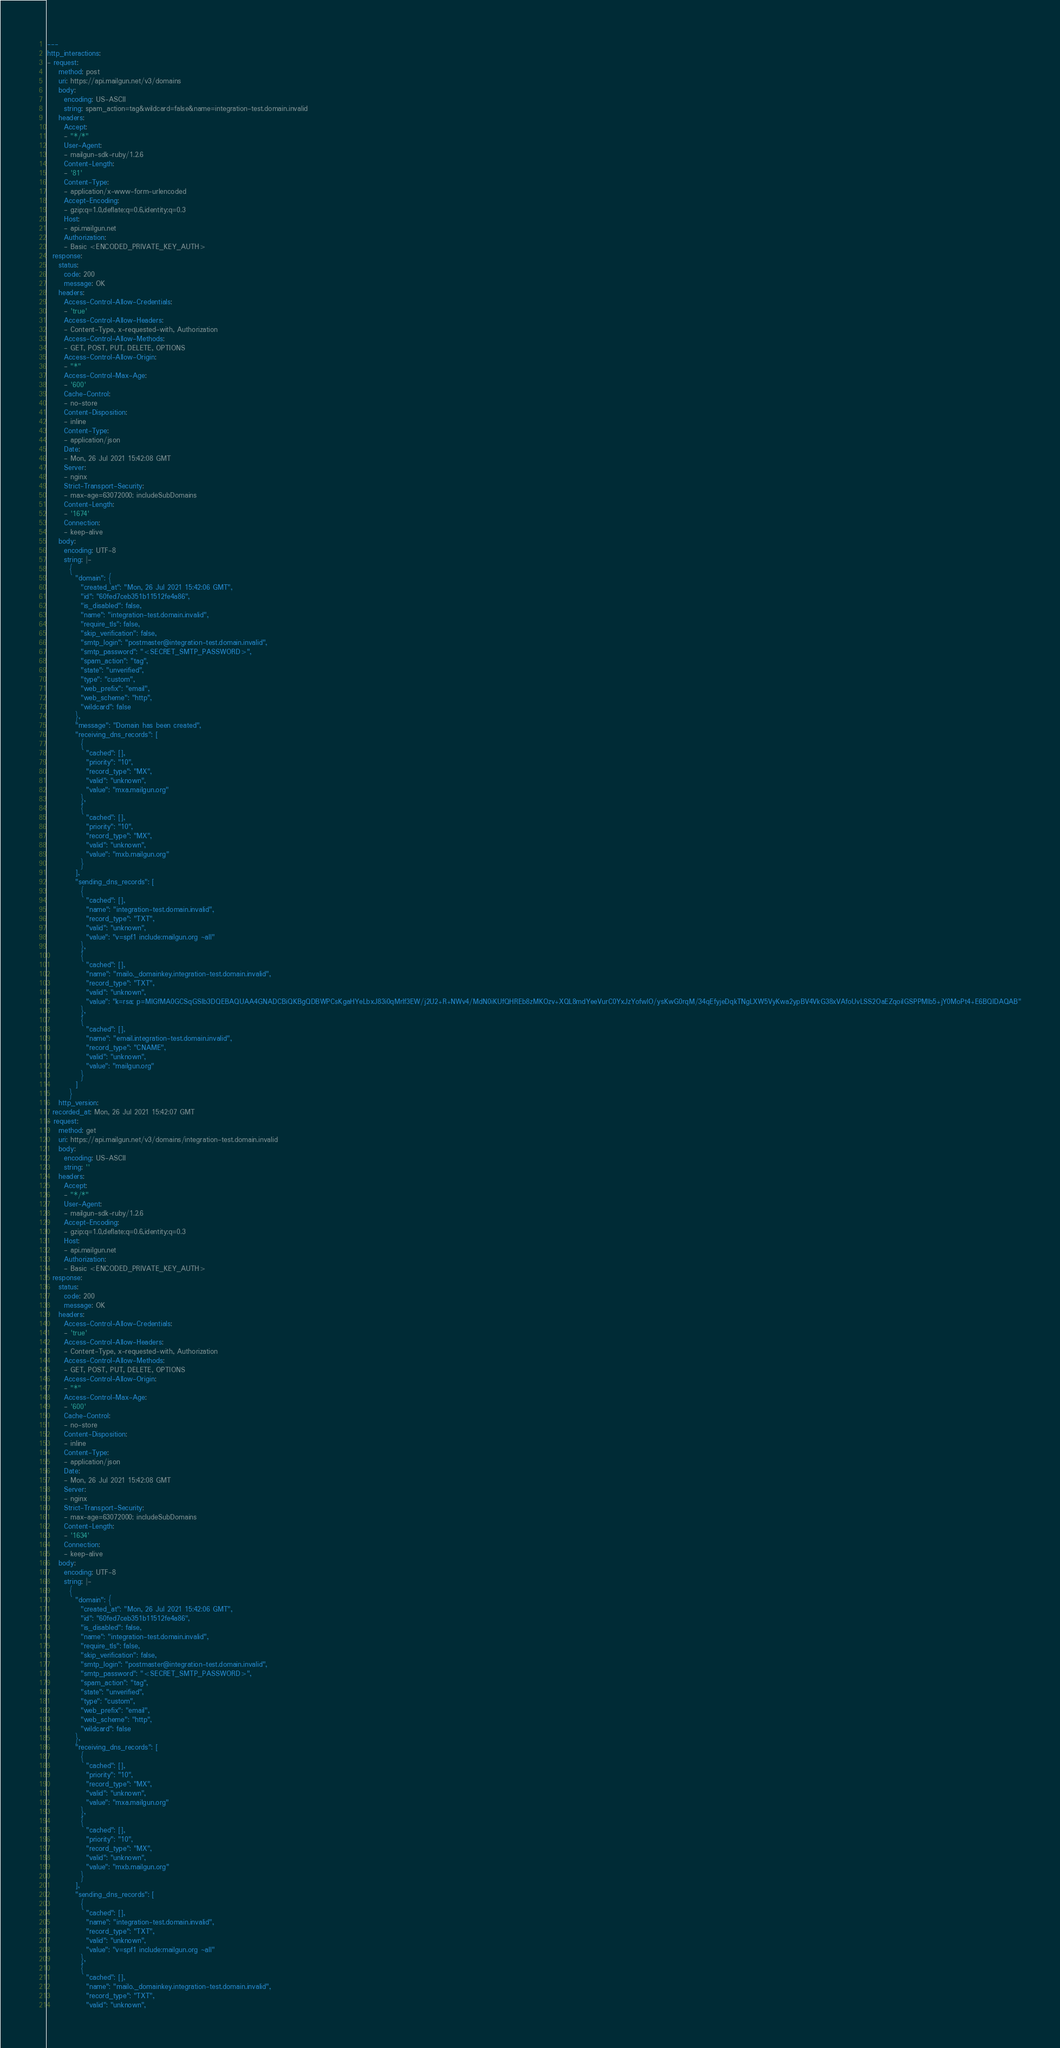Convert code to text. <code><loc_0><loc_0><loc_500><loc_500><_YAML_>---
http_interactions:
- request:
    method: post
    uri: https://api.mailgun.net/v3/domains
    body:
      encoding: US-ASCII
      string: spam_action=tag&wildcard=false&name=integration-test.domain.invalid
    headers:
      Accept:
      - "*/*"
      User-Agent:
      - mailgun-sdk-ruby/1.2.6
      Content-Length:
      - '81'
      Content-Type:
      - application/x-www-form-urlencoded
      Accept-Encoding:
      - gzip;q=1.0,deflate;q=0.6,identity;q=0.3
      Host:
      - api.mailgun.net
      Authorization:
      - Basic <ENCODED_PRIVATE_KEY_AUTH>
  response:
    status:
      code: 200
      message: OK
    headers:
      Access-Control-Allow-Credentials:
      - 'true'
      Access-Control-Allow-Headers:
      - Content-Type, x-requested-with, Authorization
      Access-Control-Allow-Methods:
      - GET, POST, PUT, DELETE, OPTIONS
      Access-Control-Allow-Origin:
      - "*"
      Access-Control-Max-Age:
      - '600'
      Cache-Control:
      - no-store
      Content-Disposition:
      - inline
      Content-Type:
      - application/json
      Date:
      - Mon, 26 Jul 2021 15:42:08 GMT
      Server:
      - nginx
      Strict-Transport-Security:
      - max-age=63072000; includeSubDomains
      Content-Length:
      - '1674'
      Connection:
      - keep-alive
    body:
      encoding: UTF-8
      string: |-
        {
          "domain": {
            "created_at": "Mon, 26 Jul 2021 15:42:06 GMT",
            "id": "60fed7ceb351b11512fe4a86",
            "is_disabled": false,
            "name": "integration-test.domain.invalid",
            "require_tls": false,
            "skip_verification": false,
            "smtp_login": "postmaster@integration-test.domain.invalid",
            "smtp_password": "<SECRET_SMTP_PASSWORD>",
            "spam_action": "tag",
            "state": "unverified",
            "type": "custom",
            "web_prefix": "email",
            "web_scheme": "http",
            "wildcard": false
          },
          "message": "Domain has been created",
          "receiving_dns_records": [
            {
              "cached": [],
              "priority": "10",
              "record_type": "MX",
              "valid": "unknown",
              "value": "mxa.mailgun.org"
            },
            {
              "cached": [],
              "priority": "10",
              "record_type": "MX",
              "valid": "unknown",
              "value": "mxb.mailgun.org"
            }
          ],
          "sending_dns_records": [
            {
              "cached": [],
              "name": "integration-test.domain.invalid",
              "record_type": "TXT",
              "valid": "unknown",
              "value": "v=spf1 include:mailgun.org ~all"
            },
            {
              "cached": [],
              "name": "mailo._domainkey.integration-test.domain.invalid",
              "record_type": "TXT",
              "valid": "unknown",
              "value": "k=rsa; p=MIGfMA0GCSqGSIb3DQEBAQUAA4GNADCBiQKBgQDBWPCsKgaHYeLbxJ83i0qMrIf3EW/j2U2+R+NWv4/MdN0iKUfQHREb8zMKOzv+XQL8mdYeeVurC0YxJzYofwlO/ysKwG0rqM/34qEfyjeDqkTNgLXW5VyKwa2ypBV4VkG38xVAfoUvLSS2OaEZqoiIGSPPMlb5+jY0MoPt4+E6BQIDAQAB"
            },
            {
              "cached": [],
              "name": "email.integration-test.domain.invalid",
              "record_type": "CNAME",
              "valid": "unknown",
              "value": "mailgun.org"
            }
          ]
        }
    http_version: 
  recorded_at: Mon, 26 Jul 2021 15:42:07 GMT
- request:
    method: get
    uri: https://api.mailgun.net/v3/domains/integration-test.domain.invalid
    body:
      encoding: US-ASCII
      string: ''
    headers:
      Accept:
      - "*/*"
      User-Agent:
      - mailgun-sdk-ruby/1.2.6
      Accept-Encoding:
      - gzip;q=1.0,deflate;q=0.6,identity;q=0.3
      Host:
      - api.mailgun.net
      Authorization:
      - Basic <ENCODED_PRIVATE_KEY_AUTH>
  response:
    status:
      code: 200
      message: OK
    headers:
      Access-Control-Allow-Credentials:
      - 'true'
      Access-Control-Allow-Headers:
      - Content-Type, x-requested-with, Authorization
      Access-Control-Allow-Methods:
      - GET, POST, PUT, DELETE, OPTIONS
      Access-Control-Allow-Origin:
      - "*"
      Access-Control-Max-Age:
      - '600'
      Cache-Control:
      - no-store
      Content-Disposition:
      - inline
      Content-Type:
      - application/json
      Date:
      - Mon, 26 Jul 2021 15:42:08 GMT
      Server:
      - nginx
      Strict-Transport-Security:
      - max-age=63072000; includeSubDomains
      Content-Length:
      - '1634'
      Connection:
      - keep-alive
    body:
      encoding: UTF-8
      string: |-
        {
          "domain": {
            "created_at": "Mon, 26 Jul 2021 15:42:06 GMT",
            "id": "60fed7ceb351b11512fe4a86",
            "is_disabled": false,
            "name": "integration-test.domain.invalid",
            "require_tls": false,
            "skip_verification": false,
            "smtp_login": "postmaster@integration-test.domain.invalid",
            "smtp_password": "<SECRET_SMTP_PASSWORD>",
            "spam_action": "tag",
            "state": "unverified",
            "type": "custom",
            "web_prefix": "email",
            "web_scheme": "http",
            "wildcard": false
          },
          "receiving_dns_records": [
            {
              "cached": [],
              "priority": "10",
              "record_type": "MX",
              "valid": "unknown",
              "value": "mxa.mailgun.org"
            },
            {
              "cached": [],
              "priority": "10",
              "record_type": "MX",
              "valid": "unknown",
              "value": "mxb.mailgun.org"
            }
          ],
          "sending_dns_records": [
            {
              "cached": [],
              "name": "integration-test.domain.invalid",
              "record_type": "TXT",
              "valid": "unknown",
              "value": "v=spf1 include:mailgun.org ~all"
            },
            {
              "cached": [],
              "name": "mailo._domainkey.integration-test.domain.invalid",
              "record_type": "TXT",
              "valid": "unknown",</code> 